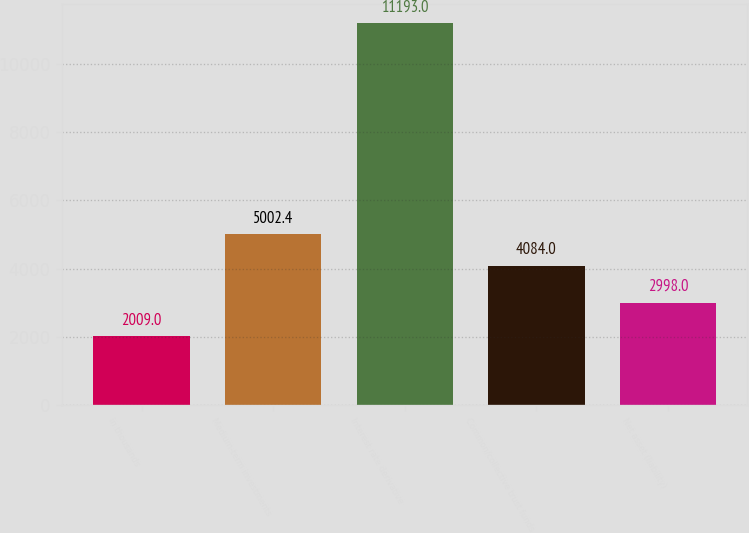Convert chart. <chart><loc_0><loc_0><loc_500><loc_500><bar_chart><fcel>in thousands<fcel>Medium-term investments<fcel>Interest rate derivative<fcel>Common/collective trust funds<fcel>Net asset (liability)<nl><fcel>2009<fcel>5002.4<fcel>11193<fcel>4084<fcel>2998<nl></chart> 